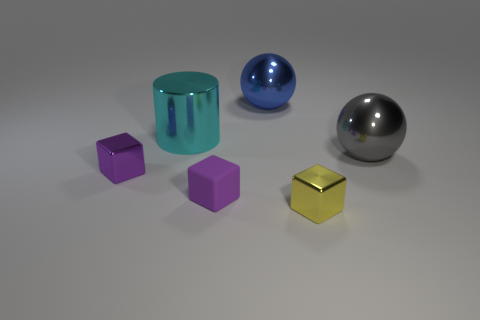How many things are either tiny purple matte blocks or brown cubes?
Your answer should be compact. 1. Is the shape of the blue thing the same as the gray metallic thing?
Your response must be concise. Yes. Is there any other thing that has the same material as the large gray object?
Offer a very short reply. Yes. Is the size of the metallic sphere that is behind the large gray object the same as the sphere to the right of the big blue metal thing?
Offer a terse response. Yes. There is a tiny block that is both on the right side of the cyan thing and behind the yellow block; what material is it?
Give a very brief answer. Rubber. Is there any other thing of the same color as the metal cylinder?
Provide a succinct answer. No. Is the number of large cyan metallic cylinders that are in front of the purple matte thing less than the number of cyan matte cylinders?
Your answer should be compact. No. Is the number of gray shiny things greater than the number of balls?
Make the answer very short. No. Are there any small things that are behind the tiny shiny cube in front of the tiny metallic thing to the left of the tiny yellow object?
Offer a terse response. Yes. How many other objects are there of the same size as the cyan object?
Keep it short and to the point. 2. 